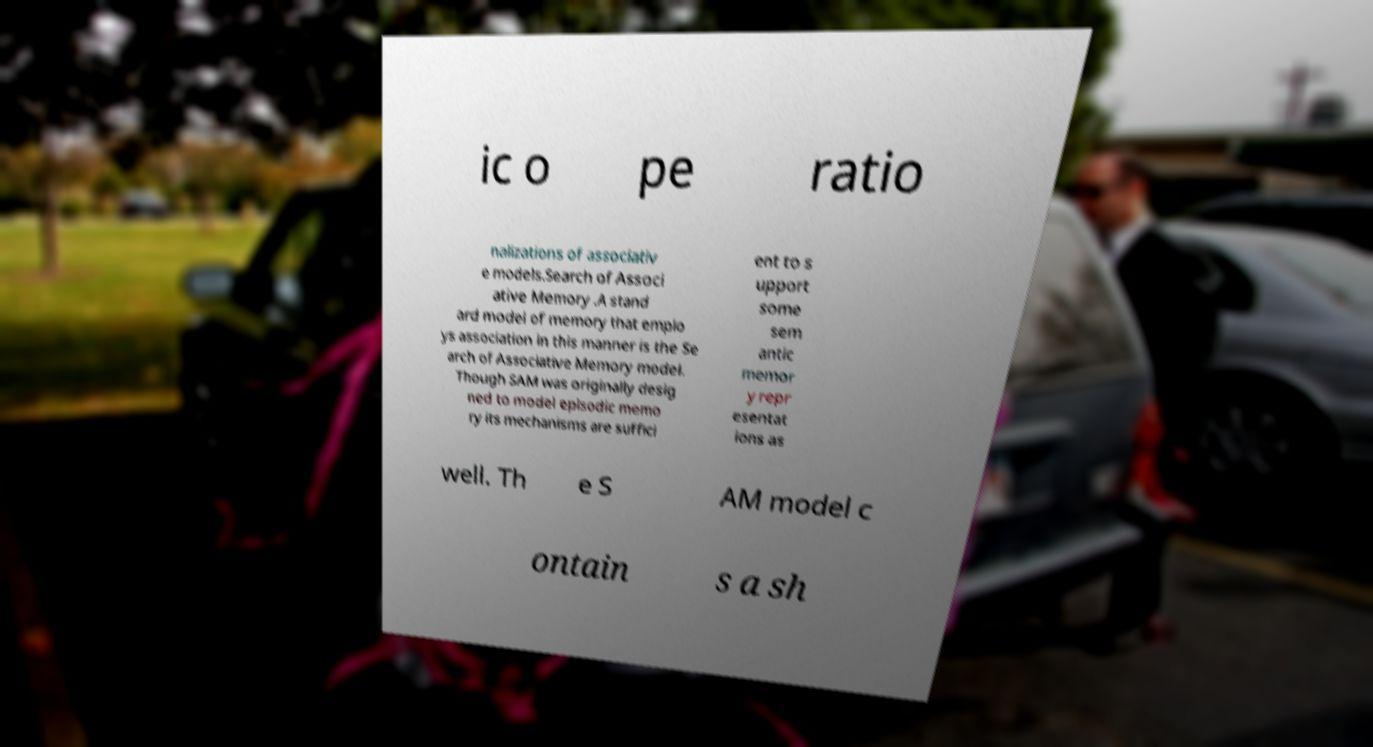Can you read and provide the text displayed in the image?This photo seems to have some interesting text. Can you extract and type it out for me? ic o pe ratio nalizations of associativ e models.Search of Associ ative Memory .A stand ard model of memory that emplo ys association in this manner is the Se arch of Associative Memory model. Though SAM was originally desig ned to model episodic memo ry its mechanisms are suffici ent to s upport some sem antic memor y repr esentat ions as well. Th e S AM model c ontain s a sh 